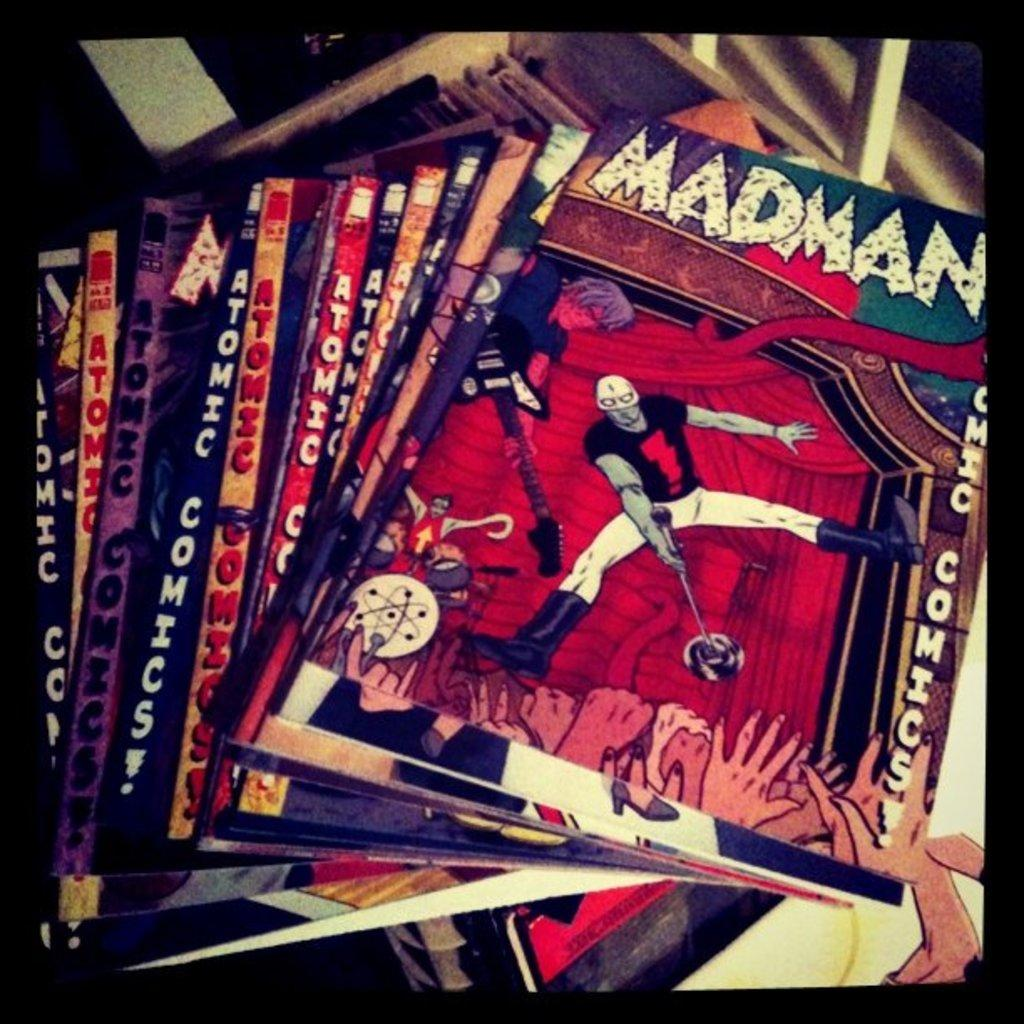What objects are present in the image? There are books in the image. What can be found on the books? There is text on the books. What type of illustrations are on the books? There are cartoon images of persons on the books. What type of sticks can be seen in the image? There are no sticks present in the image. What month is depicted in the image? The image does not depict a specific month; it features books with text and cartoon images of persons. 